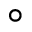<formula> <loc_0><loc_0><loc_500><loc_500>^ { \circ }</formula> 